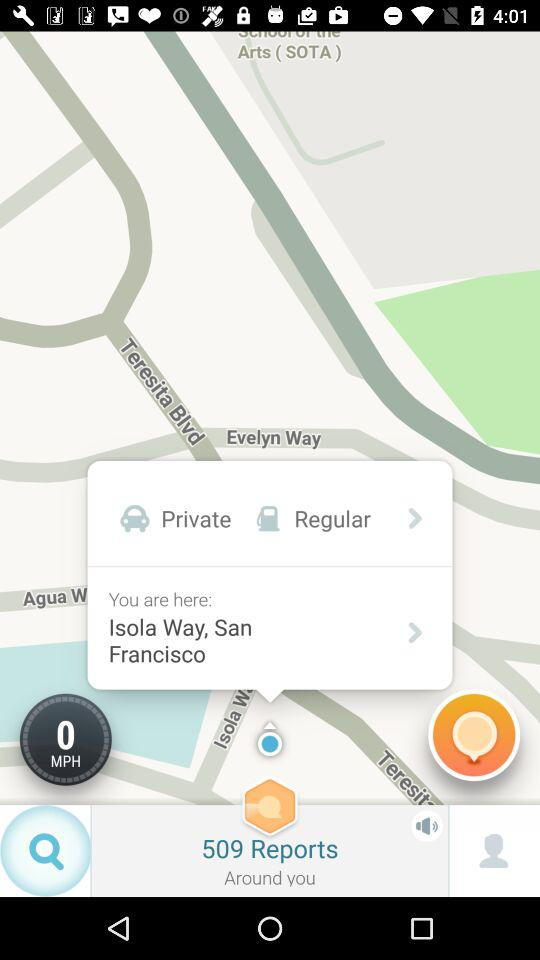How many reports are there in total?
Answer the question using a single word or phrase. 509 